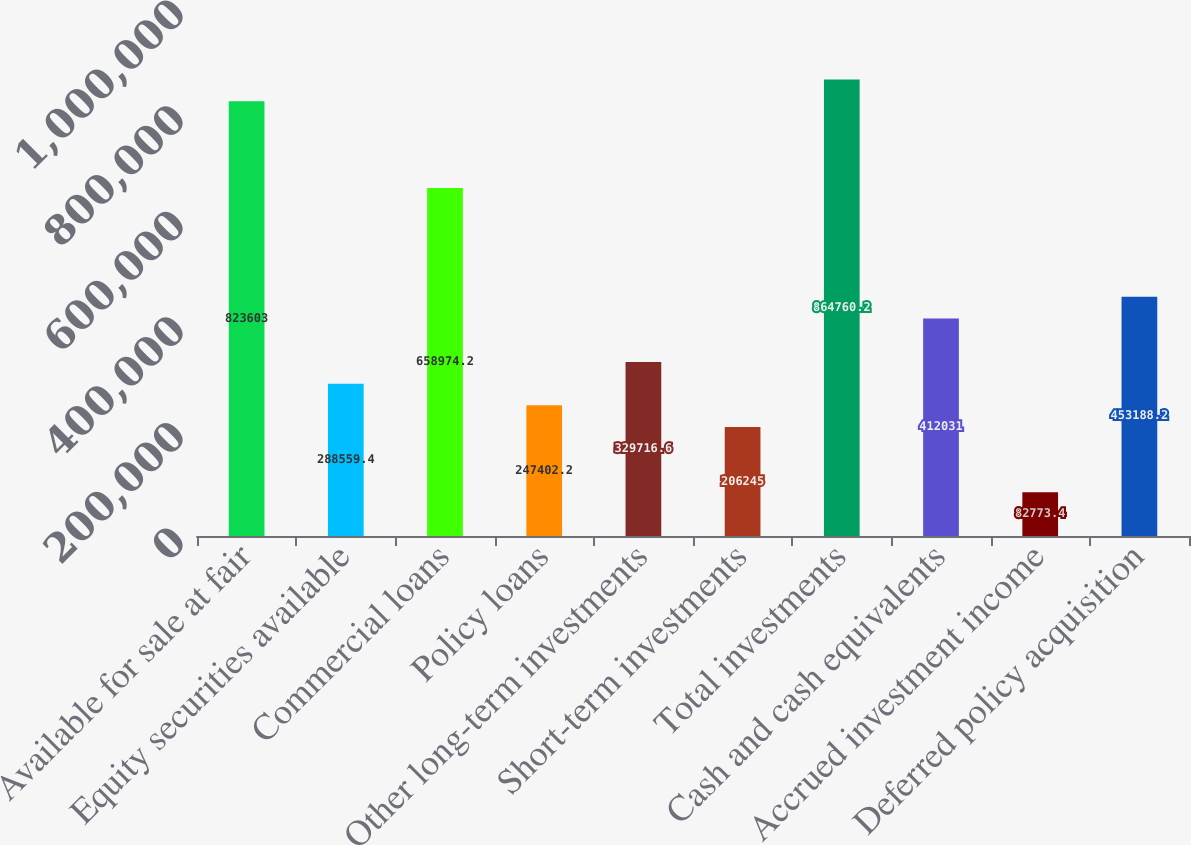Convert chart. <chart><loc_0><loc_0><loc_500><loc_500><bar_chart><fcel>Available for sale at fair<fcel>Equity securities available<fcel>Commercial loans<fcel>Policy loans<fcel>Other long-term investments<fcel>Short-term investments<fcel>Total investments<fcel>Cash and cash equivalents<fcel>Accrued investment income<fcel>Deferred policy acquisition<nl><fcel>823603<fcel>288559<fcel>658974<fcel>247402<fcel>329717<fcel>206245<fcel>864760<fcel>412031<fcel>82773.4<fcel>453188<nl></chart> 